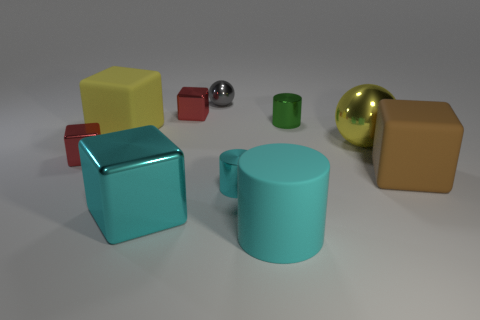The tiny metal thing that is right of the big cyan matte cylinder has what shape?
Keep it short and to the point. Cylinder. Are there any other things that have the same color as the big matte cylinder?
Offer a very short reply. Yes. Is the number of big metal blocks that are to the right of the cyan metallic block less than the number of small red blocks?
Provide a short and direct response. Yes. What number of matte cubes have the same size as the gray sphere?
Ensure brevity in your answer.  0. What is the shape of the small thing that is the same color as the rubber cylinder?
Offer a terse response. Cylinder. What shape is the yellow thing left of the tiny cylinder that is left of the cylinder that is behind the large yellow sphere?
Provide a short and direct response. Cube. What color is the metallic ball in front of the gray metallic thing?
Give a very brief answer. Yellow. How many objects are either large rubber objects to the left of the tiny gray object or green objects left of the brown matte cube?
Offer a terse response. 2. How many big brown rubber things have the same shape as the gray thing?
Your answer should be compact. 0. What color is the metallic cube that is the same size as the cyan rubber cylinder?
Ensure brevity in your answer.  Cyan. 